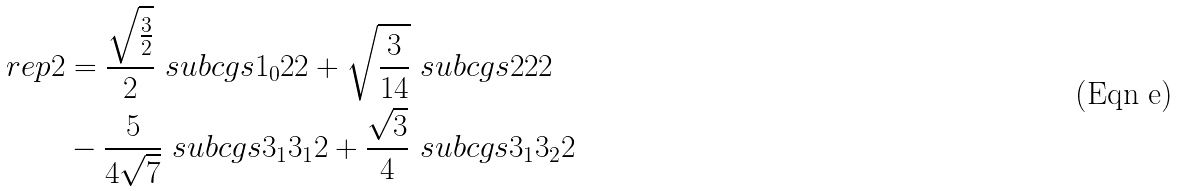Convert formula to latex. <formula><loc_0><loc_0><loc_500><loc_500>\ r e p { 2 } & = \frac { \sqrt { \frac { 3 } { 2 } } } { 2 } \ s u b c g s { 1 _ { 0 } } { 2 } { 2 } + \sqrt { \frac { 3 } { 1 4 } } \ s u b c g s { 2 } { 2 } { 2 } \\ & - \frac { 5 } { 4 \sqrt { 7 } } \ s u b c g s { 3 _ { 1 } } { 3 _ { 1 } } { 2 } + \frac { \sqrt { 3 } } { 4 } \ s u b c g s { 3 _ { 1 } } { 3 _ { 2 } } { 2 }</formula> 